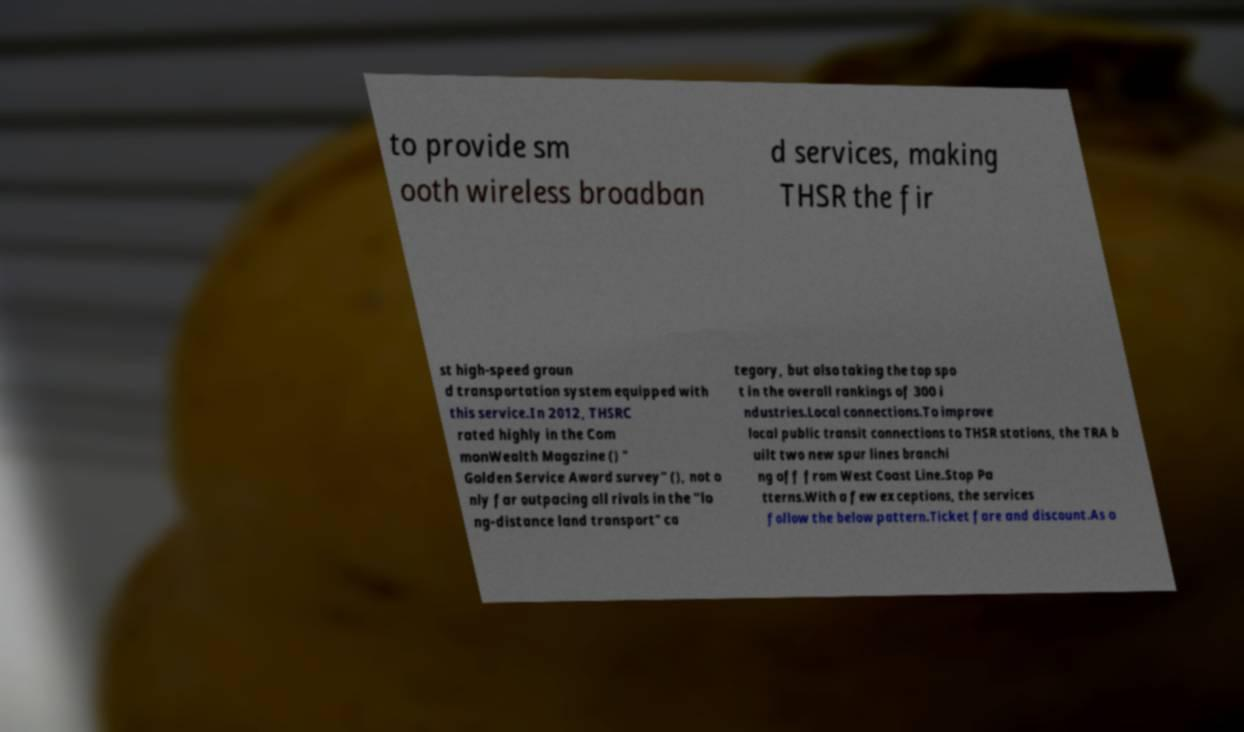For documentation purposes, I need the text within this image transcribed. Could you provide that? to provide sm ooth wireless broadban d services, making THSR the fir st high-speed groun d transportation system equipped with this service.In 2012, THSRC rated highly in the Com monWealth Magazine () " Golden Service Award survey" (), not o nly far outpacing all rivals in the "lo ng-distance land transport" ca tegory, but also taking the top spo t in the overall rankings of 300 i ndustries.Local connections.To improve local public transit connections to THSR stations, the TRA b uilt two new spur lines branchi ng off from West Coast Line.Stop Pa tterns.With a few exceptions, the services follow the below pattern.Ticket fare and discount.As o 